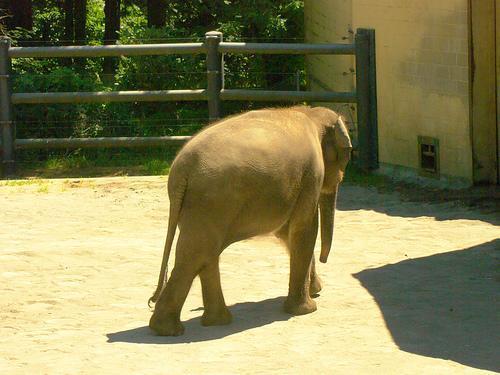How many legs does the elephant have?
Give a very brief answer. 4. 